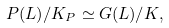<formula> <loc_0><loc_0><loc_500><loc_500>P ( L ) / K _ { P } \simeq G ( L ) / K ,</formula> 